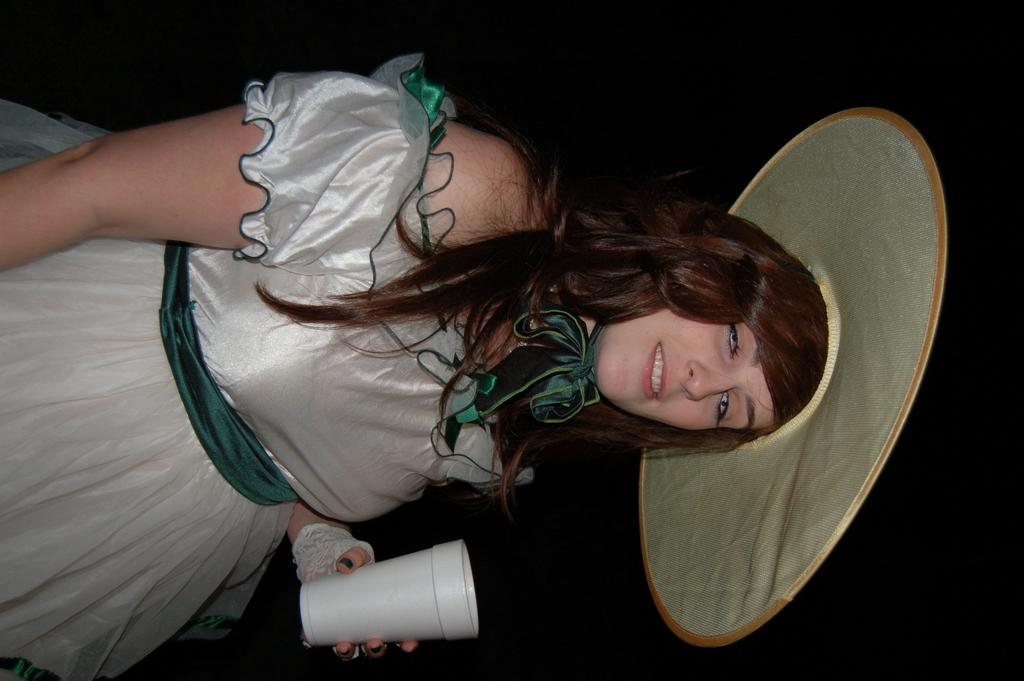Who is present in the image? There is a woman in the image. What is the woman doing in the image? The woman is smiling in the image. What is the woman wearing on her head? The woman is wearing a hat in the image. What is the woman holding in the image? The woman is holding a glass in the image. What can be observed about the background of the image? The background of the image is dark. What type of magic is the woman performing in the image? There is no magic or any indication of magic being performed in the image. 